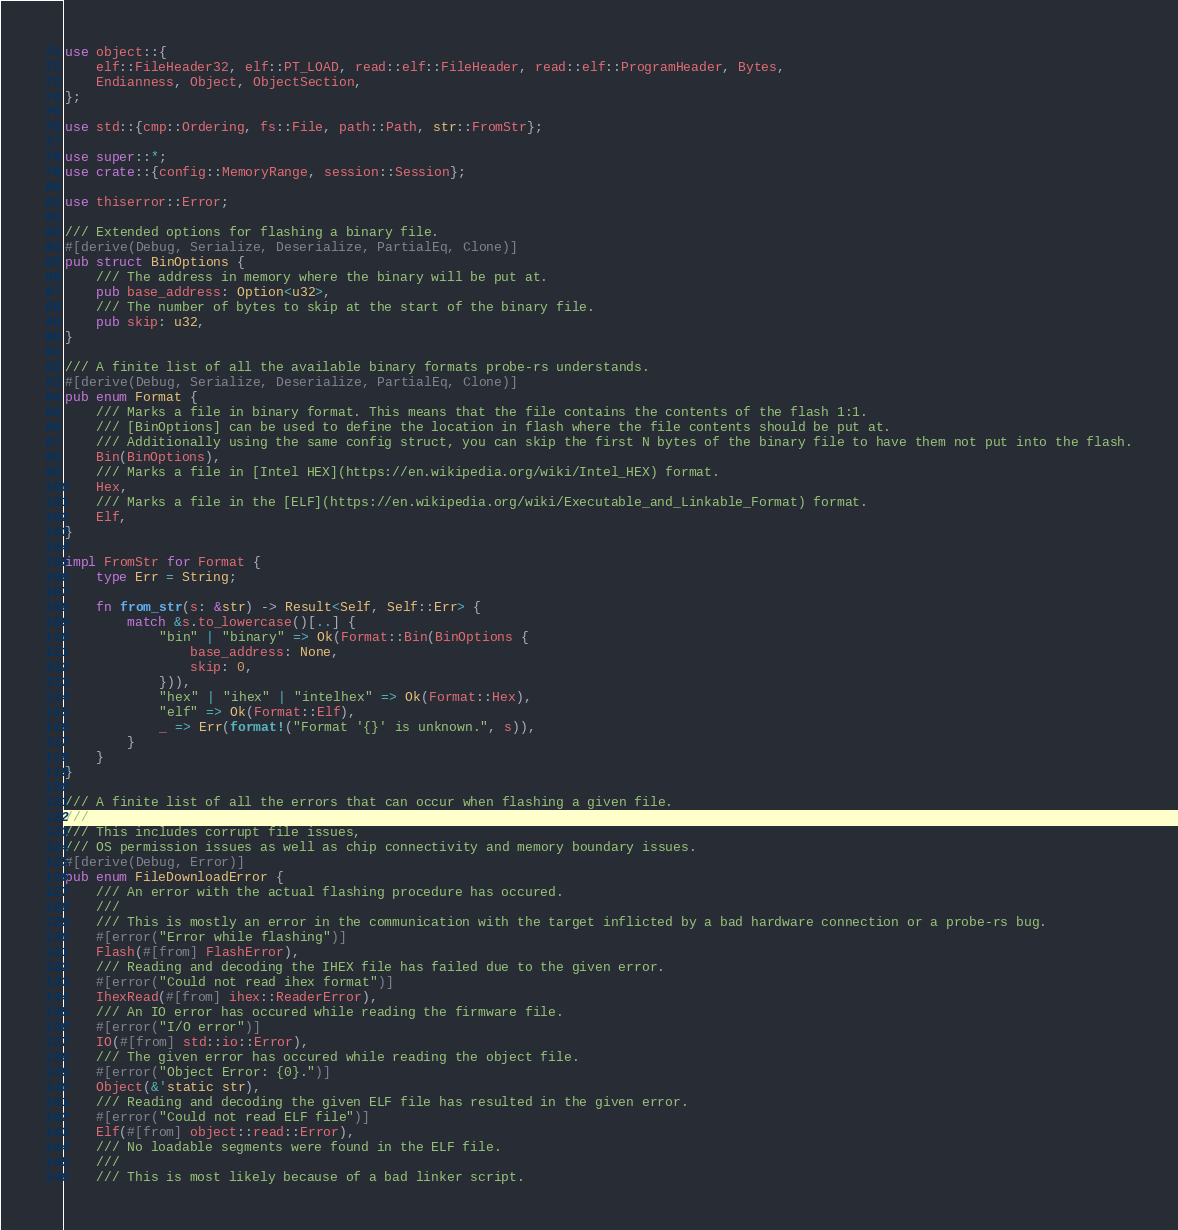Convert code to text. <code><loc_0><loc_0><loc_500><loc_500><_Rust_>use object::{
    elf::FileHeader32, elf::PT_LOAD, read::elf::FileHeader, read::elf::ProgramHeader, Bytes,
    Endianness, Object, ObjectSection,
};

use std::{cmp::Ordering, fs::File, path::Path, str::FromStr};

use super::*;
use crate::{config::MemoryRange, session::Session};

use thiserror::Error;

/// Extended options for flashing a binary file.
#[derive(Debug, Serialize, Deserialize, PartialEq, Clone)]
pub struct BinOptions {
    /// The address in memory where the binary will be put at.
    pub base_address: Option<u32>,
    /// The number of bytes to skip at the start of the binary file.
    pub skip: u32,
}

/// A finite list of all the available binary formats probe-rs understands.
#[derive(Debug, Serialize, Deserialize, PartialEq, Clone)]
pub enum Format {
    /// Marks a file in binary format. This means that the file contains the contents of the flash 1:1.
    /// [BinOptions] can be used to define the location in flash where the file contents should be put at.
    /// Additionally using the same config struct, you can skip the first N bytes of the binary file to have them not put into the flash.
    Bin(BinOptions),
    /// Marks a file in [Intel HEX](https://en.wikipedia.org/wiki/Intel_HEX) format.
    Hex,
    /// Marks a file in the [ELF](https://en.wikipedia.org/wiki/Executable_and_Linkable_Format) format.
    Elf,
}

impl FromStr for Format {
    type Err = String;

    fn from_str(s: &str) -> Result<Self, Self::Err> {
        match &s.to_lowercase()[..] {
            "bin" | "binary" => Ok(Format::Bin(BinOptions {
                base_address: None,
                skip: 0,
            })),
            "hex" | "ihex" | "intelhex" => Ok(Format::Hex),
            "elf" => Ok(Format::Elf),
            _ => Err(format!("Format '{}' is unknown.", s)),
        }
    }
}

/// A finite list of all the errors that can occur when flashing a given file.
///
/// This includes corrupt file issues,
/// OS permission issues as well as chip connectivity and memory boundary issues.
#[derive(Debug, Error)]
pub enum FileDownloadError {
    /// An error with the actual flashing procedure has occured.
    ///
    /// This is mostly an error in the communication with the target inflicted by a bad hardware connection or a probe-rs bug.
    #[error("Error while flashing")]
    Flash(#[from] FlashError),
    /// Reading and decoding the IHEX file has failed due to the given error.
    #[error("Could not read ihex format")]
    IhexRead(#[from] ihex::ReaderError),
    /// An IO error has occured while reading the firmware file.
    #[error("I/O error")]
    IO(#[from] std::io::Error),
    /// The given error has occured while reading the object file.
    #[error("Object Error: {0}.")]
    Object(&'static str),
    /// Reading and decoding the given ELF file has resulted in the given error.
    #[error("Could not read ELF file")]
    Elf(#[from] object::read::Error),
    /// No loadable segments were found in the ELF file.
    ///
    /// This is most likely because of a bad linker script.</code> 